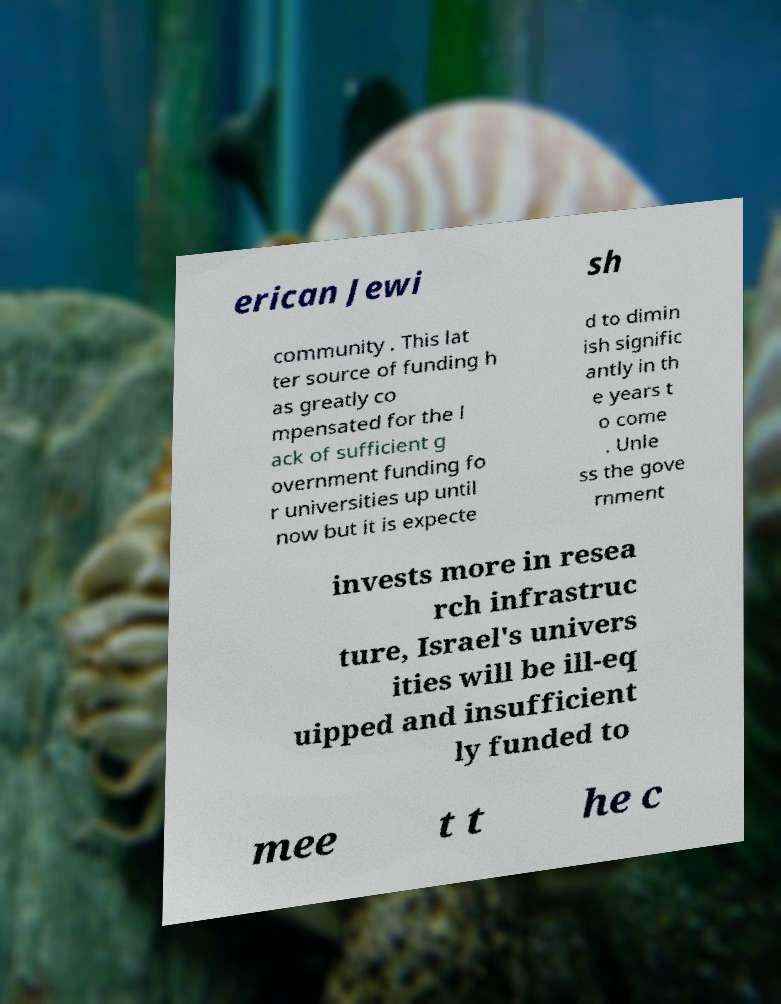For documentation purposes, I need the text within this image transcribed. Could you provide that? erican Jewi sh community . This lat ter source of funding h as greatly co mpensated for the l ack of sufficient g overnment funding fo r universities up until now but it is expecte d to dimin ish signific antly in th e years t o come . Unle ss the gove rnment invests more in resea rch infrastruc ture, Israel's univers ities will be ill-eq uipped and insufficient ly funded to mee t t he c 